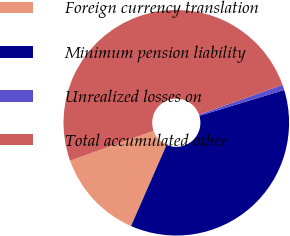Convert chart. <chart><loc_0><loc_0><loc_500><loc_500><pie_chart><fcel>Foreign currency translation<fcel>Minimum pension liability<fcel>Unrealized losses on<fcel>Total accumulated other<nl><fcel>12.98%<fcel>36.26%<fcel>0.76%<fcel>50.0%<nl></chart> 